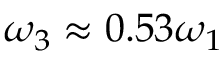<formula> <loc_0><loc_0><loc_500><loc_500>\omega _ { 3 } \approx 0 . 5 3 \omega _ { 1 }</formula> 